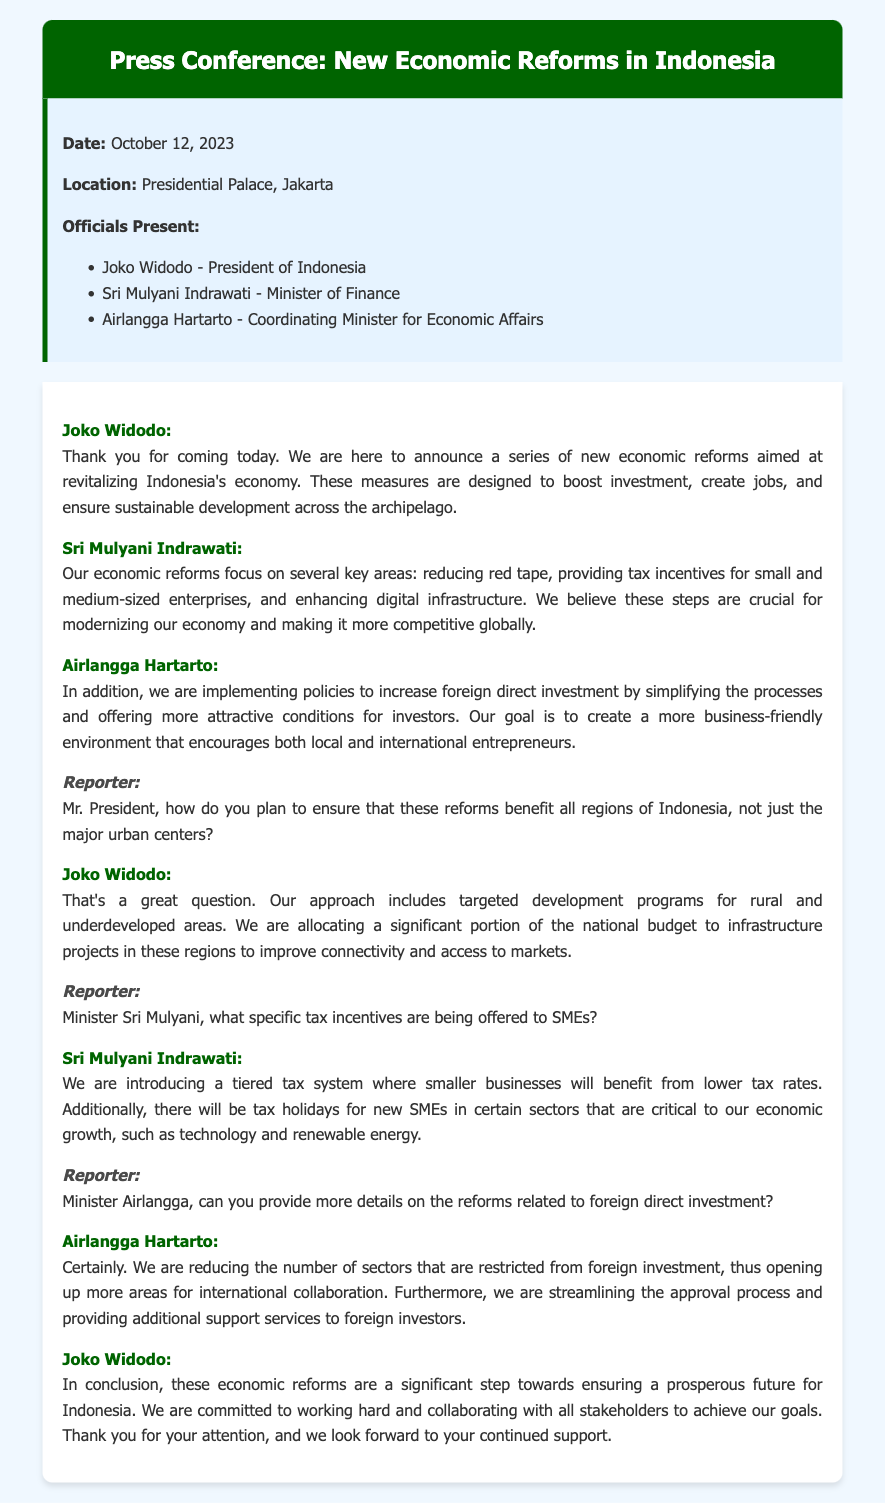What is the date of the press conference? The date is mentioned at the beginning of the document.
Answer: October 12, 2023 Who is the President of Indonesia? The document lists the officials present at the conference.
Answer: Joko Widodo What is the primary focus of the economic reforms mentioned? The focus areas are highlighted in the statements from government officials.
Answer: Revitalizing Indonesia's economy What are the key areas identified by Sri Mulyani for economic reforms? The document provides specific areas that the Minister of Finance focuses on.
Answer: Reducing red tape, tax incentives, digital infrastructure What kind of tax system is being introduced for SMEs? The document outlines the tax incentives specifically for SMEs.
Answer: Tiered tax system How does Joko Widodo plan to support rural areas with the reforms? The President mentions specific strategies for rural development in his response.
Answer: Targeted development programs What is one of the specific benefits for new SMEs as mentioned by Sri Mulyani? The Minister details incentives available for new SMEs.
Answer: Tax holidays Which minister discussed reforms related to foreign direct investment? The speakers listed in the document indicate who addressed foreign direct investment.
Answer: Airlangga Hartarto What is one action mentioned by Airlangga Hartarto to boost foreign investment? The document discusses measures to facilitate foreign investment.
Answer: Reducing restrictions on sectors 